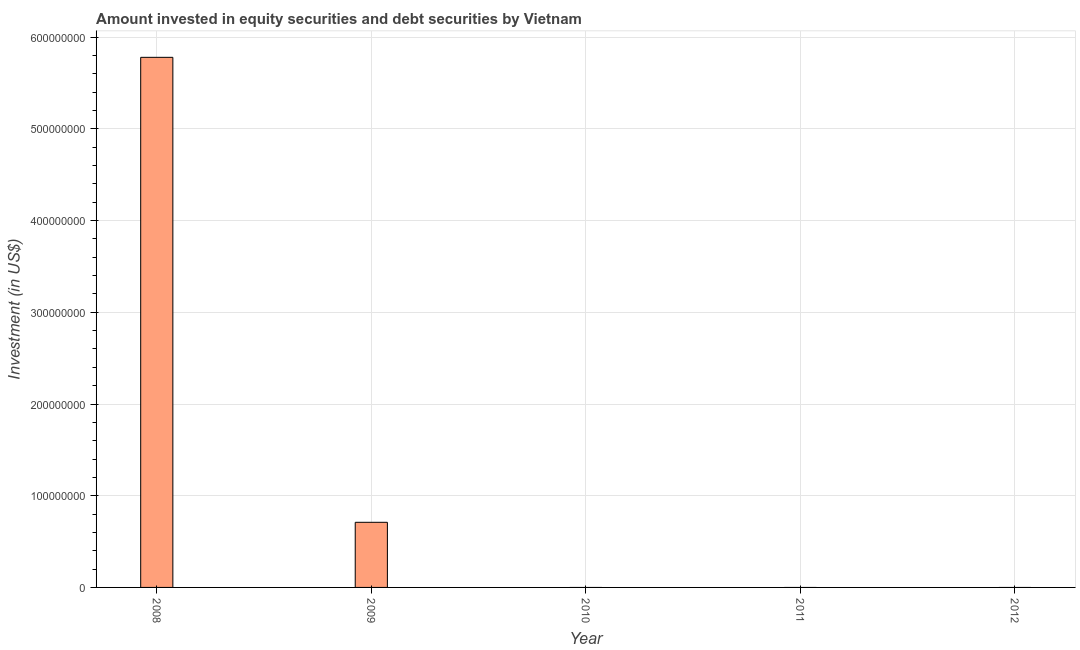Does the graph contain any zero values?
Keep it short and to the point. Yes. What is the title of the graph?
Provide a short and direct response. Amount invested in equity securities and debt securities by Vietnam. What is the label or title of the X-axis?
Your answer should be compact. Year. What is the label or title of the Y-axis?
Provide a short and direct response. Investment (in US$). What is the portfolio investment in 2009?
Your answer should be compact. 7.10e+07. Across all years, what is the maximum portfolio investment?
Offer a very short reply. 5.78e+08. In which year was the portfolio investment maximum?
Provide a succinct answer. 2008. What is the sum of the portfolio investment?
Ensure brevity in your answer.  6.49e+08. What is the difference between the portfolio investment in 2008 and 2009?
Your answer should be very brief. 5.07e+08. What is the average portfolio investment per year?
Provide a short and direct response. 1.30e+08. What is the difference between the highest and the lowest portfolio investment?
Your answer should be very brief. 5.78e+08. How many bars are there?
Keep it short and to the point. 2. How many years are there in the graph?
Give a very brief answer. 5. Are the values on the major ticks of Y-axis written in scientific E-notation?
Ensure brevity in your answer.  No. What is the Investment (in US$) of 2008?
Offer a terse response. 5.78e+08. What is the Investment (in US$) in 2009?
Your response must be concise. 7.10e+07. What is the Investment (in US$) in 2011?
Provide a short and direct response. 0. What is the Investment (in US$) in 2012?
Provide a succinct answer. 0. What is the difference between the Investment (in US$) in 2008 and 2009?
Make the answer very short. 5.07e+08. What is the ratio of the Investment (in US$) in 2008 to that in 2009?
Provide a succinct answer. 8.14. 